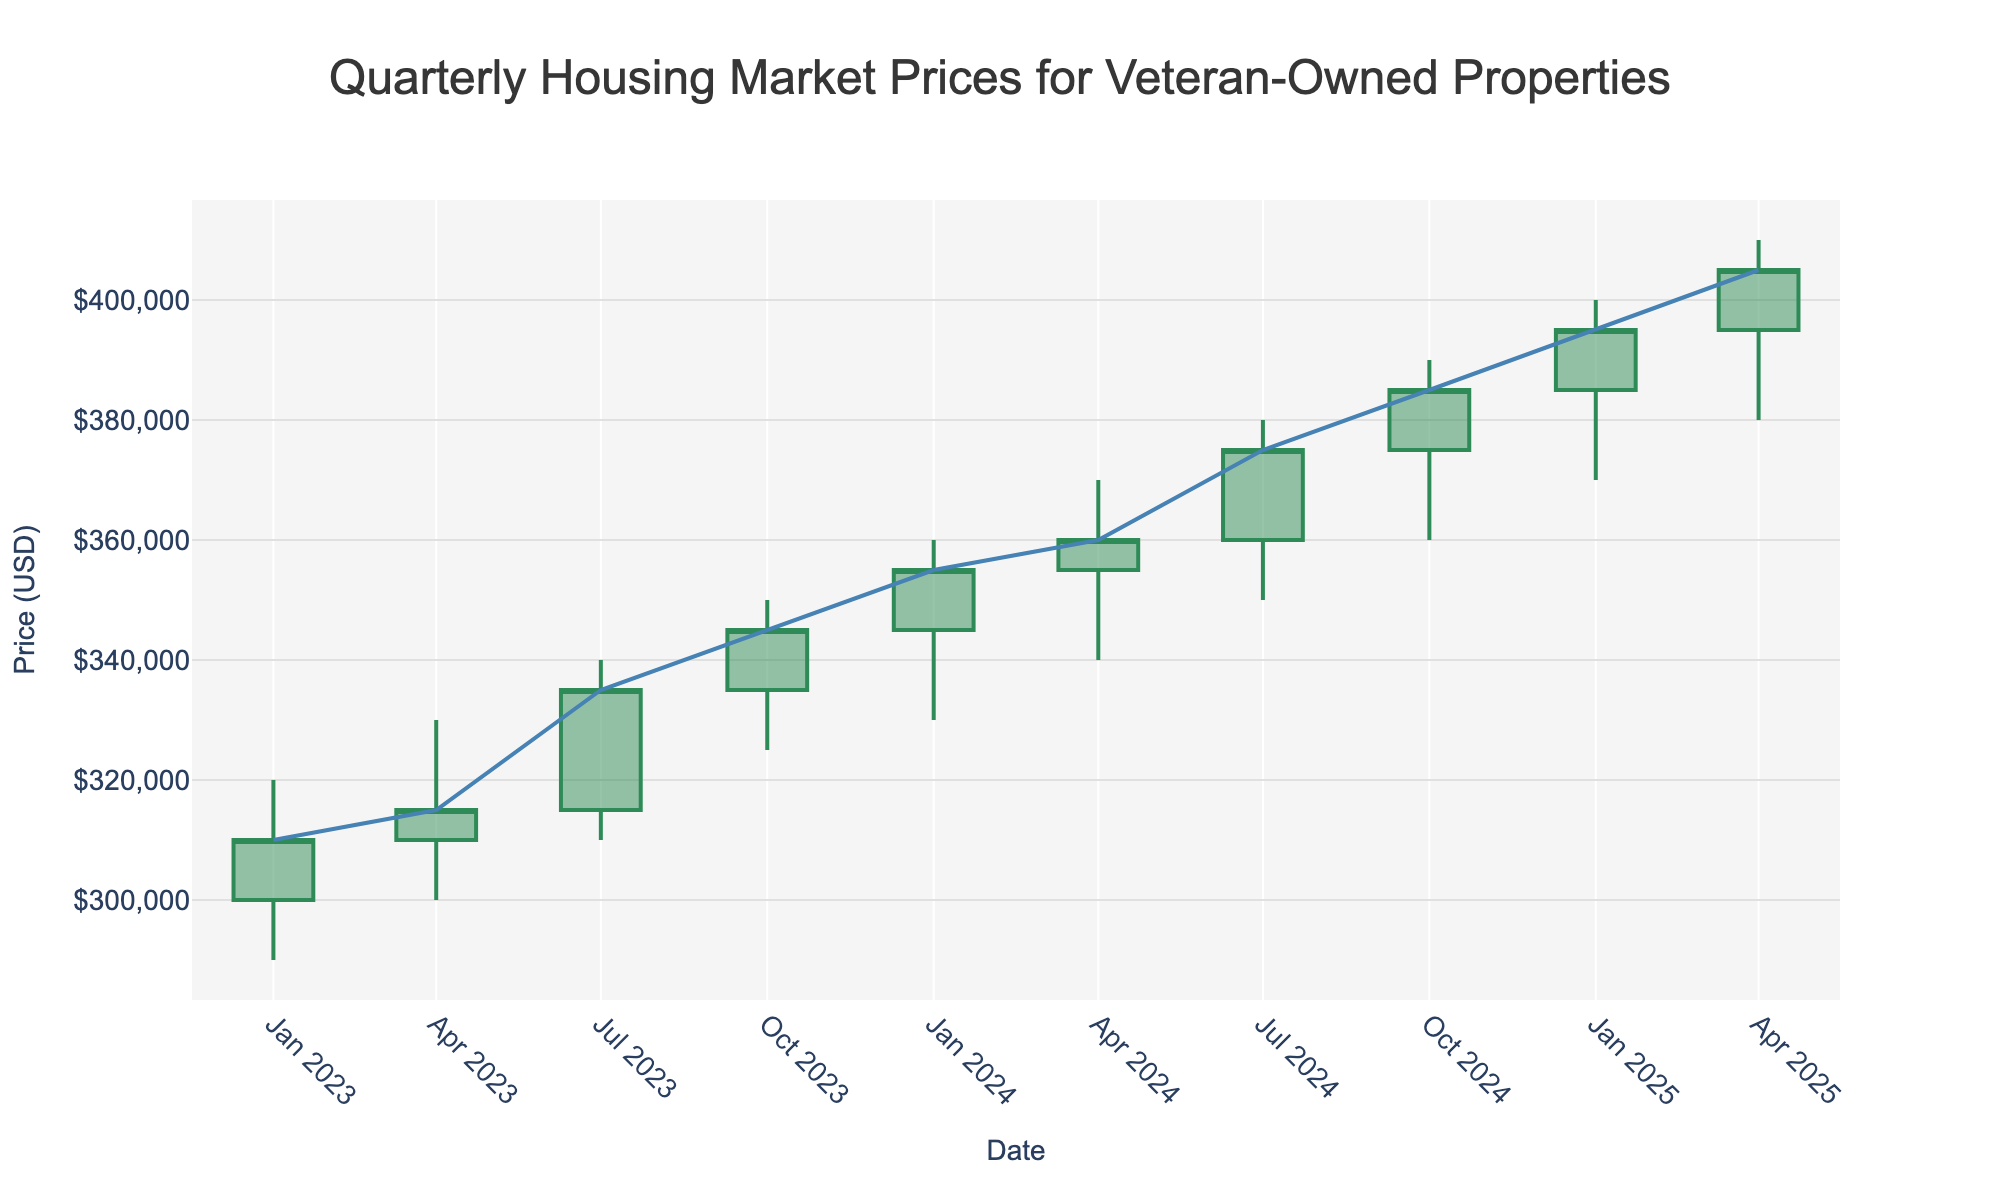What is the title of the plot? The title is displayed at the top center of the plot and reads "Quarterly Housing Market Prices for Veteran-Owned Properties".
Answer: Quarterly Housing Market Prices for Veteran-Owned Properties What are the units of the y-axis? The y-axis is labeled with "Price (USD)", indicating that the units are in U.S. Dollars.
Answer: U.S. Dollars On which date does the highest closing price occur? The highest closing price can be seen by looking at the last data point on the x-axis, which corresponds to the date "2025-04-01".
Answer: 2025-04-01 What is the closing price on 2023-10-01? The closing price for any specific date can be identified by looking at the respective candlestick on the plot; for "2023-10-01", it is $345,000, as derived from the 'Close' value.
Answer: $345,000 Between which dates did the largest increase in closing price occur? By comparing the closing prices between consecutive dates, the largest jump occurs from "2024-07-01" ($375,000) to "2024-10-01" ($385,000), an increase of $10,000.
Answer: 2024-07-01 to 2024-10-01 What is the average closing price for 2024? The closing prices for 2024 are $355,000, $360,000, $375,000, and $385,000. Summing them gives $1,475,000, and the average is $1,475,000 / 4 = $368,750.
Answer: $368,750 Which quarter had the lowest opening price in the data? Looking at the opening prices for each quarter, the lowest value of $300,000 is seen on "2023-01-01".
Answer: 2023-01-01 How many quarterly data points are included in the plot? Each candlestick represents a quarterly data point, and counting all candlesticks from "2023-01-01" to "2025-04-01" gives a total of 10 data points.
Answer: 10 What is the trend of the market over the time period shown? Observing the trend line added to the plot, it shows a consistent upward trajectory from the beginning to the end.
Answer: Upward trend How does the low price on 2025-01-01 compare to the low price on 2023-01-01? The low price on "2025-01-01" is $370,000, while on "2023-01-01" it is $290,000. $370,000 is higher than $290,000 by $80,000.
Answer: $80,000 higher 